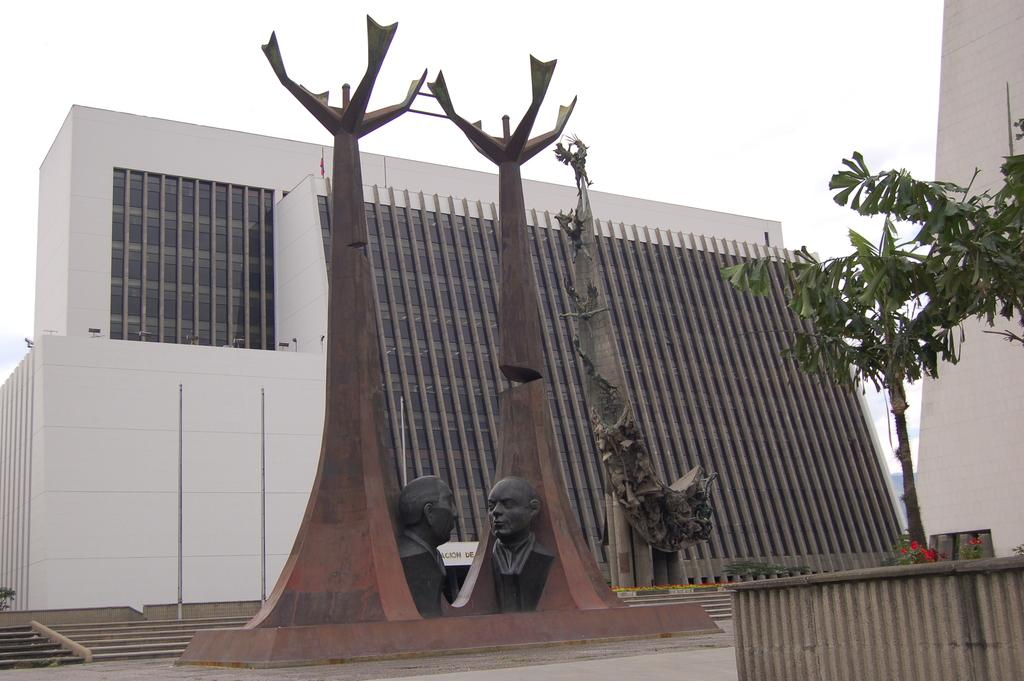What is the main structure in the image? There is a building in the image. What can be seen in the middle of the image? There are three sculptures in the middle of the image. What type of vegetation is on the right side of the image? There are plants on the right side of the image. What is visible in the background of the image? The sky is visible in the background of the image. What type of pear is hanging from the building in the image? There is no pear present in the image; it features a building, sculptures, plants, and the sky. 